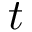Convert formula to latex. <formula><loc_0><loc_0><loc_500><loc_500>t</formula> 